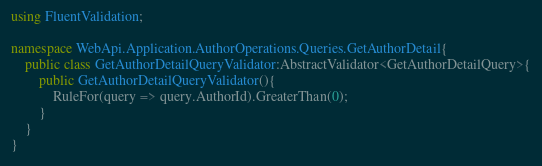Convert code to text. <code><loc_0><loc_0><loc_500><loc_500><_C#_>using FluentValidation;

namespace WebApi.Application.AuthorOperations.Queries.GetAuthorDetail{
    public class GetAuthorDetailQueryValidator:AbstractValidator<GetAuthorDetailQuery>{
        public GetAuthorDetailQueryValidator(){
            RuleFor(query => query.AuthorId).GreaterThan(0);
        }
    }
}
</code> 